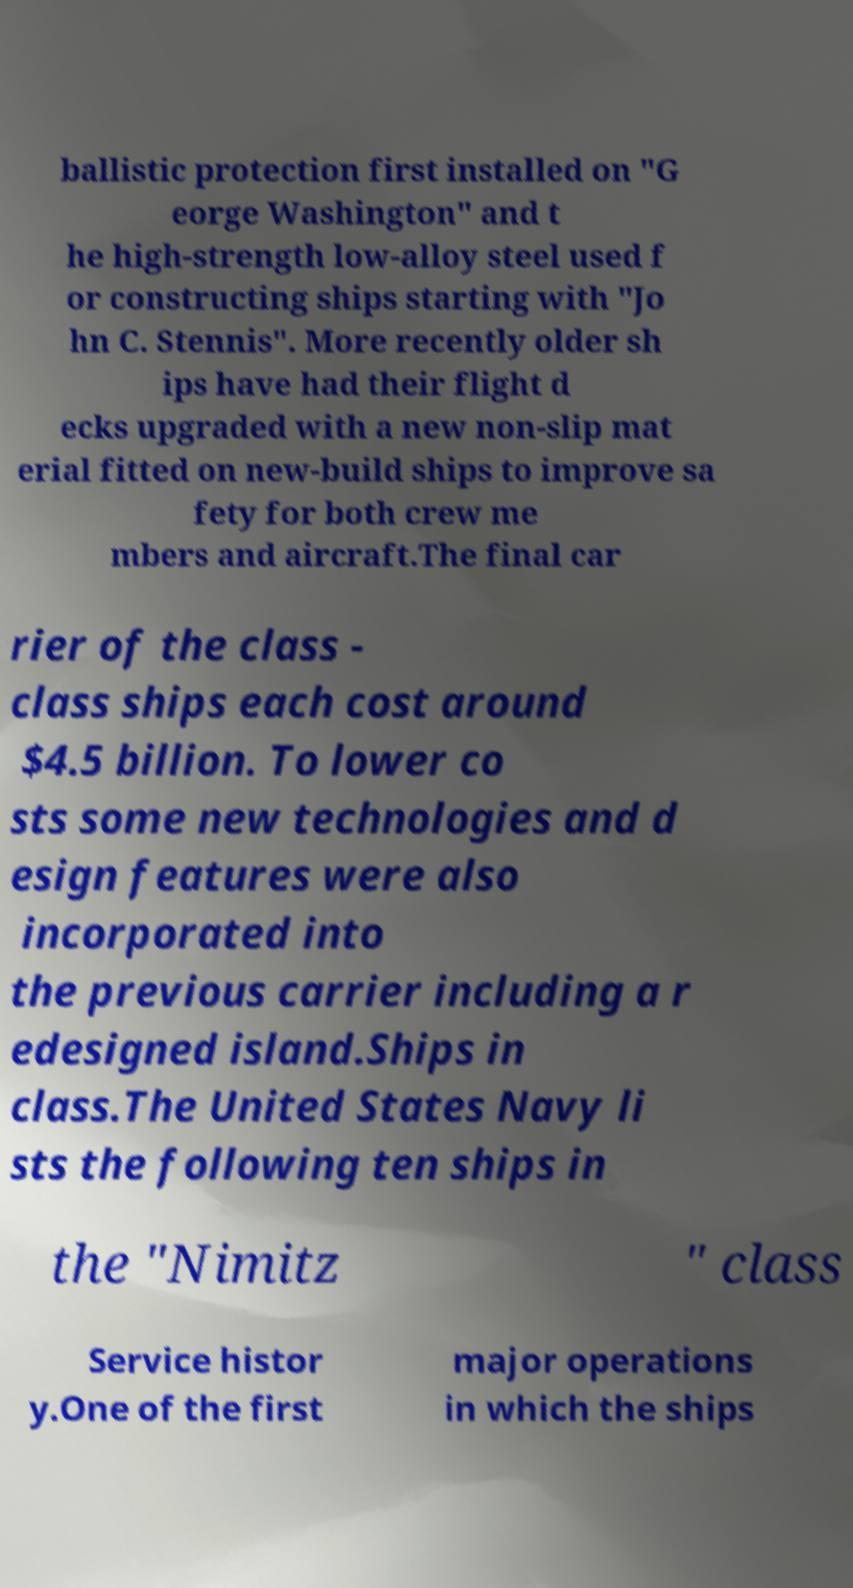Could you assist in decoding the text presented in this image and type it out clearly? ballistic protection first installed on "G eorge Washington" and t he high-strength low-alloy steel used f or constructing ships starting with "Jo hn C. Stennis". More recently older sh ips have had their flight d ecks upgraded with a new non-slip mat erial fitted on new-build ships to improve sa fety for both crew me mbers and aircraft.The final car rier of the class - class ships each cost around $4.5 billion. To lower co sts some new technologies and d esign features were also incorporated into the previous carrier including a r edesigned island.Ships in class.The United States Navy li sts the following ten ships in the "Nimitz " class Service histor y.One of the first major operations in which the ships 